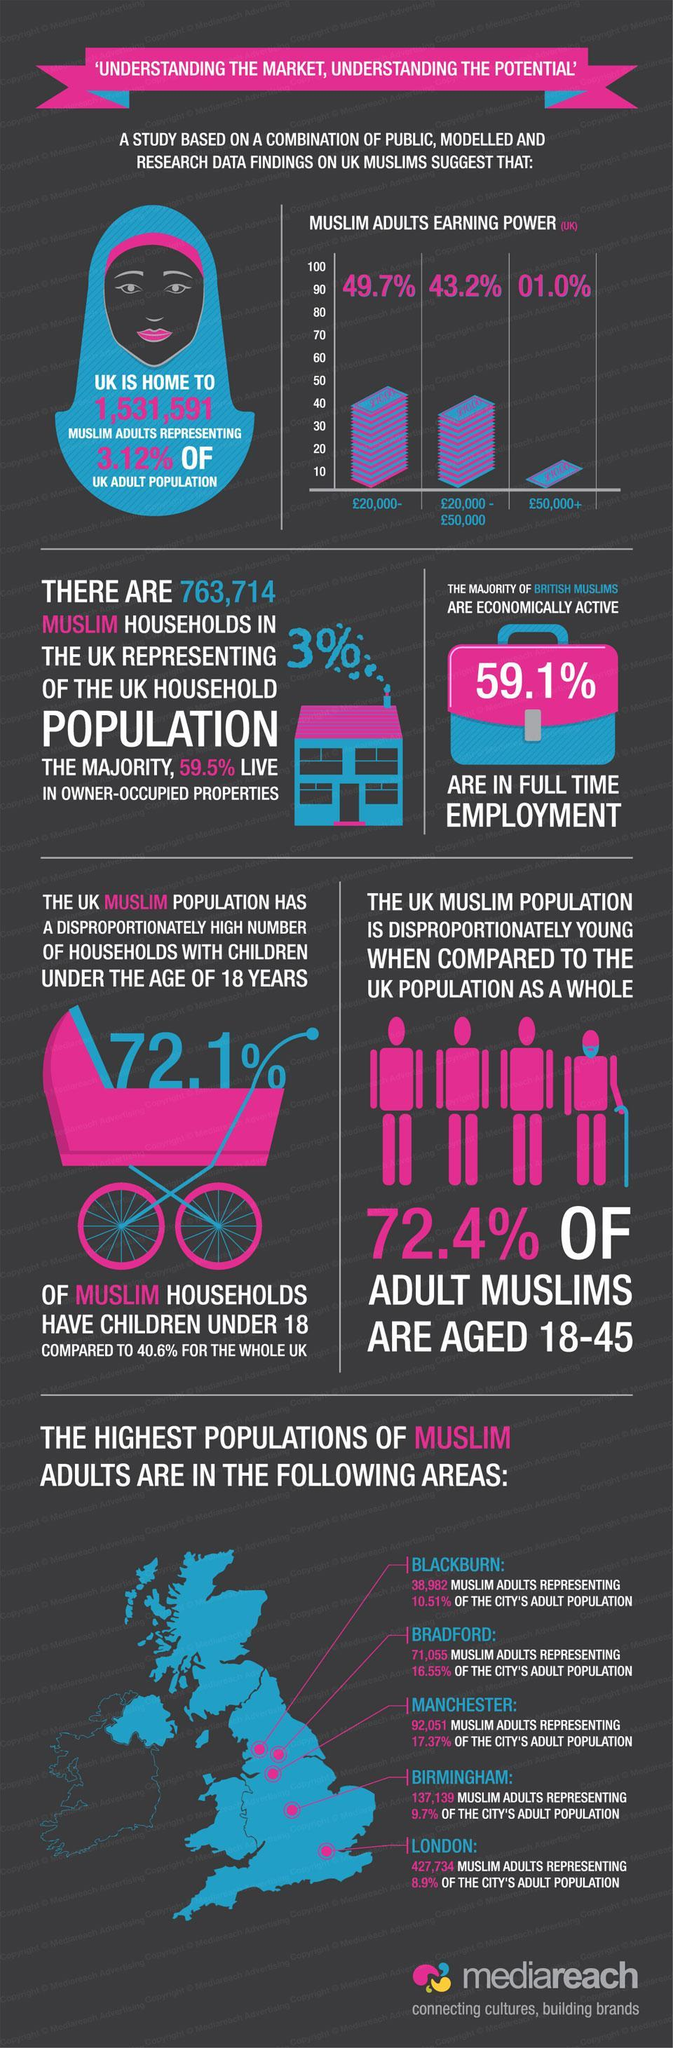What % of UK household are occupied by Muslims
Answer the question with a short phrase. 3% What % of adult population are represented by Muslims in UK 3.12% What is the colour of the walking stick, pink or blue blue After London which is the area which has the most muslim adult population Birmingham What % of muslim households have children under 18 72.1% What is the total count of muslim adult population in Blackburn and Bradford 110037 What is the earning potential 43.2% of the population 20,000 - 50,000 